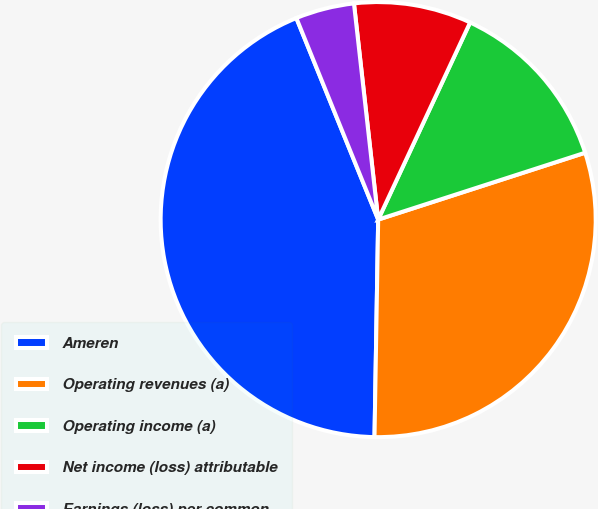Convert chart. <chart><loc_0><loc_0><loc_500><loc_500><pie_chart><fcel>Ameren<fcel>Operating revenues (a)<fcel>Operating income (a)<fcel>Net income (loss) attributable<fcel>Earnings (loss) per common<nl><fcel>43.59%<fcel>30.24%<fcel>13.08%<fcel>8.72%<fcel>4.36%<nl></chart> 